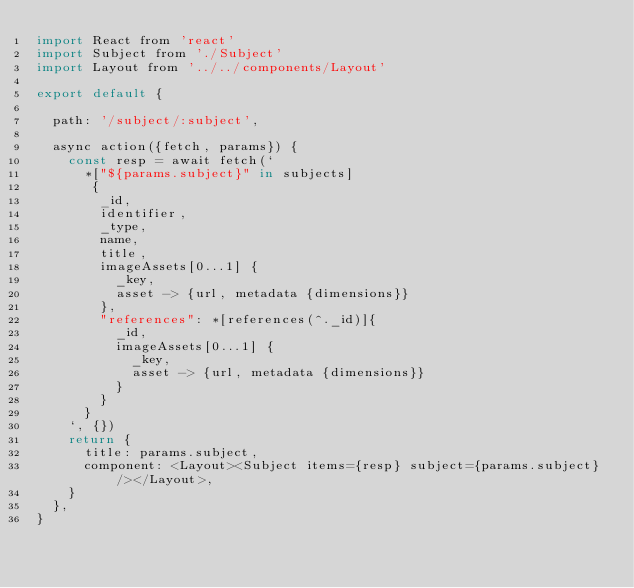Convert code to text. <code><loc_0><loc_0><loc_500><loc_500><_JavaScript_>import React from 'react'
import Subject from './Subject'
import Layout from '../../components/Layout'

export default {

  path: '/subject/:subject',

  async action({fetch, params}) {
    const resp = await fetch(`
      *["${params.subject}" in subjects]
       {
        _id,
        identifier,
        _type,
        name,
        title,
        imageAssets[0...1] {
          _key,
          asset -> {url, metadata {dimensions}}
        },
        "references": *[references(^._id)]{
          _id,
          imageAssets[0...1] {
            _key,
            asset -> {url, metadata {dimensions}}
          }
        }
      }
    `, {})
    return {
      title: params.subject,
      component: <Layout><Subject items={resp} subject={params.subject} /></Layout>,
    }
  },
}
</code> 